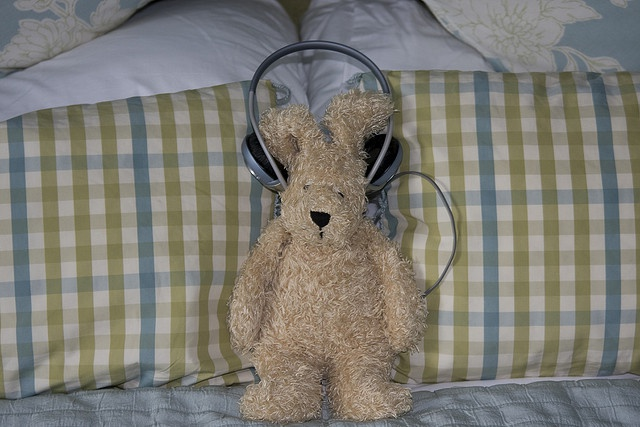Describe the objects in this image and their specific colors. I can see bed in gray and darkgray tones and teddy bear in gray and darkgray tones in this image. 